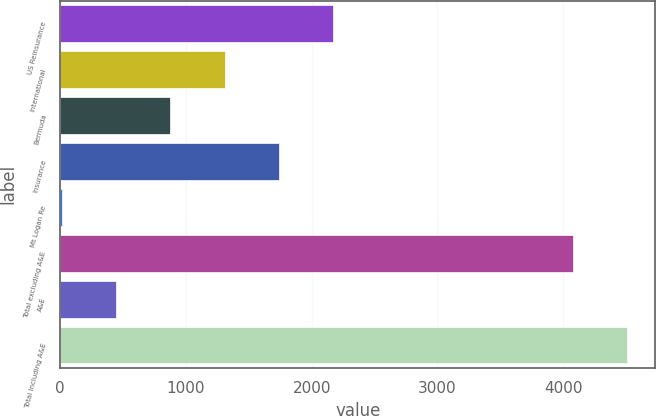<chart> <loc_0><loc_0><loc_500><loc_500><bar_chart><fcel>US Reinsurance<fcel>International<fcel>Bermuda<fcel>Insurance<fcel>Mt Logan Re<fcel>Total excluding A&E<fcel>A&E<fcel>Total including A&E<nl><fcel>2170.6<fcel>1307.56<fcel>876.04<fcel>1739.08<fcel>13<fcel>4077.1<fcel>444.52<fcel>4508.62<nl></chart> 